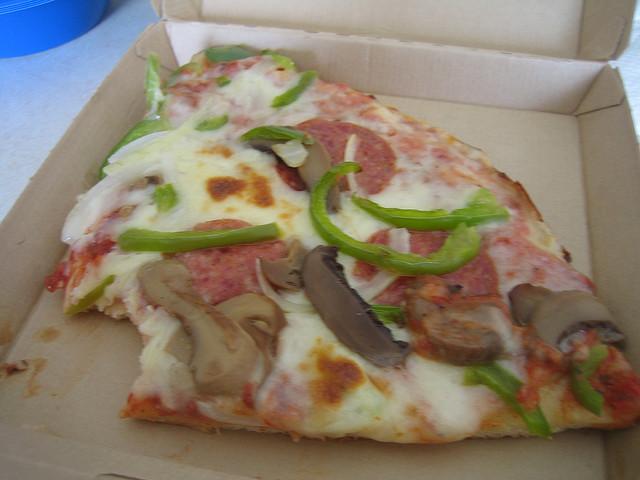Is the pizza greasy?
Quick response, please. No. How many vegetables are in this scene?
Keep it brief. 2. What kind of meat is on the pizza?
Write a very short answer. Pepperoni. What type of food is this?
Concise answer only. Pizza. What meat is shown here?
Quick response, please. Pepperoni. What kind of sliced peppers are on the pizza?
Be succinct. Green. Has the meal started?
Give a very brief answer. Yes. Is this dish vegetarian?
Short answer required. No. Is the cheese melted?
Concise answer only. Yes. Does this look like a healthy meal?
Concise answer only. No. Is this a normal pizza topping?
Answer briefly. Yes. Is the lid plastic?
Give a very brief answer. No. 